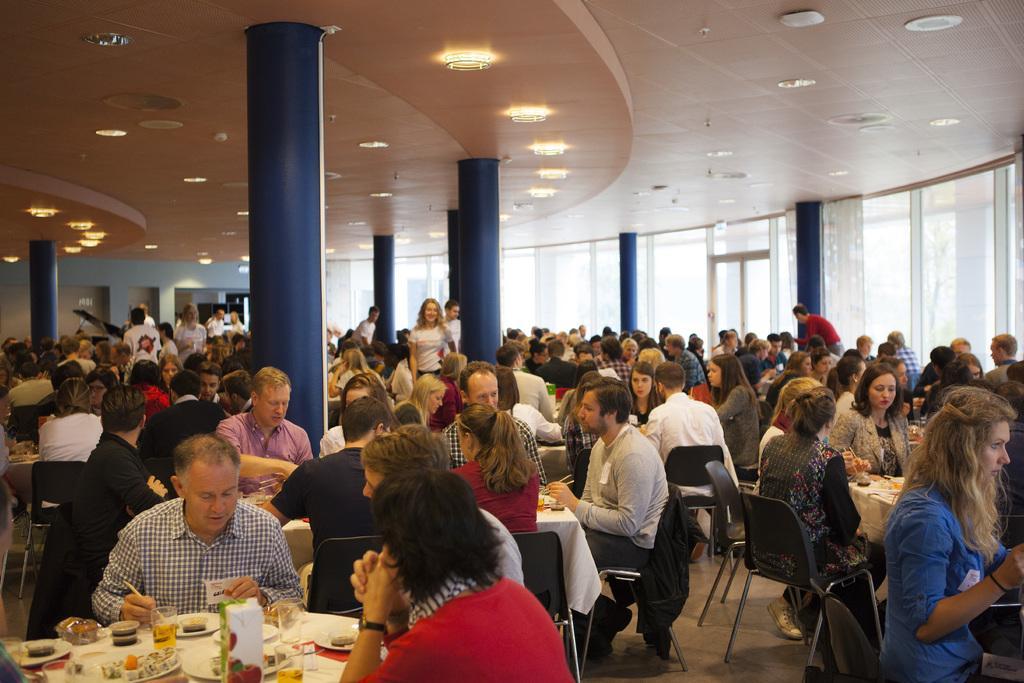How would you summarize this image in a sentence or two? In this image there are group of persons sitting and standing. In the front there are persons sitting and there is a table, on the table there are the glasses, bottles And there is food and in the background there are persons standing and there are pillars which are blue in colour. On the top there are lights and there are windows in the background. 